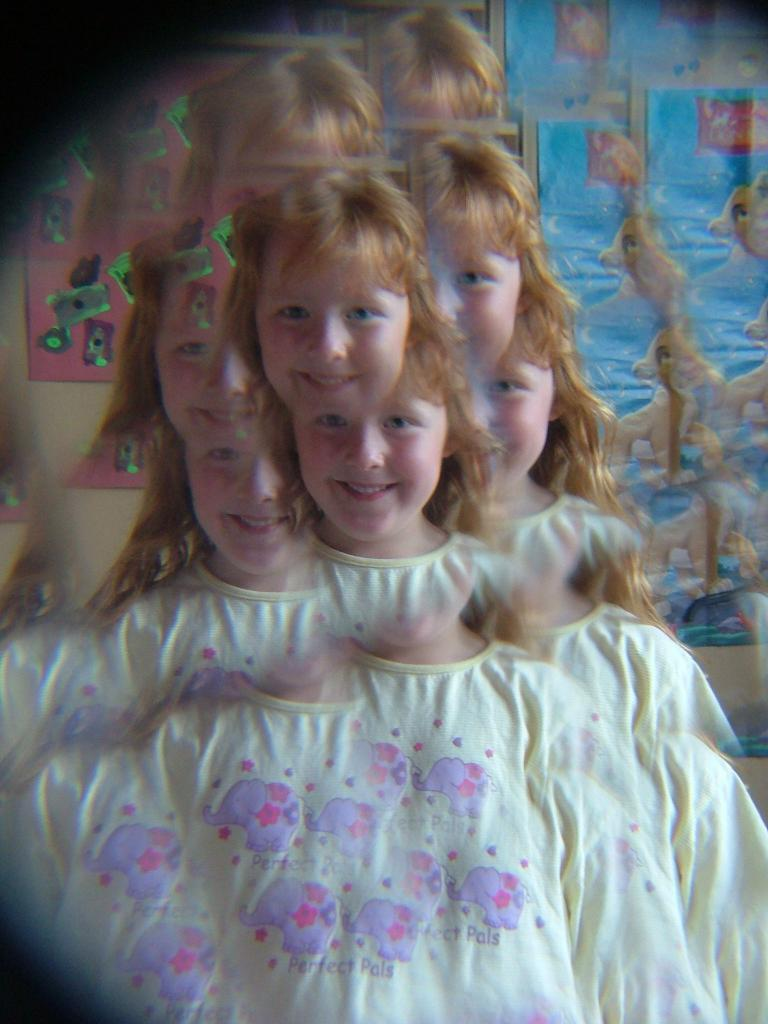Who is the main subject in the picture? There is a girl in the picture. What is the girl doing in the image? The girl is smiling. What is the girl wearing in the picture? The girl is wearing a white top. Can you tell if the image has been altered or edited? Yes, the image appears to be edited. What type of rice is being used in the invention depicted in the image? There is no rice or invention present in the image; it features a girl who is smiling and wearing a white top. 